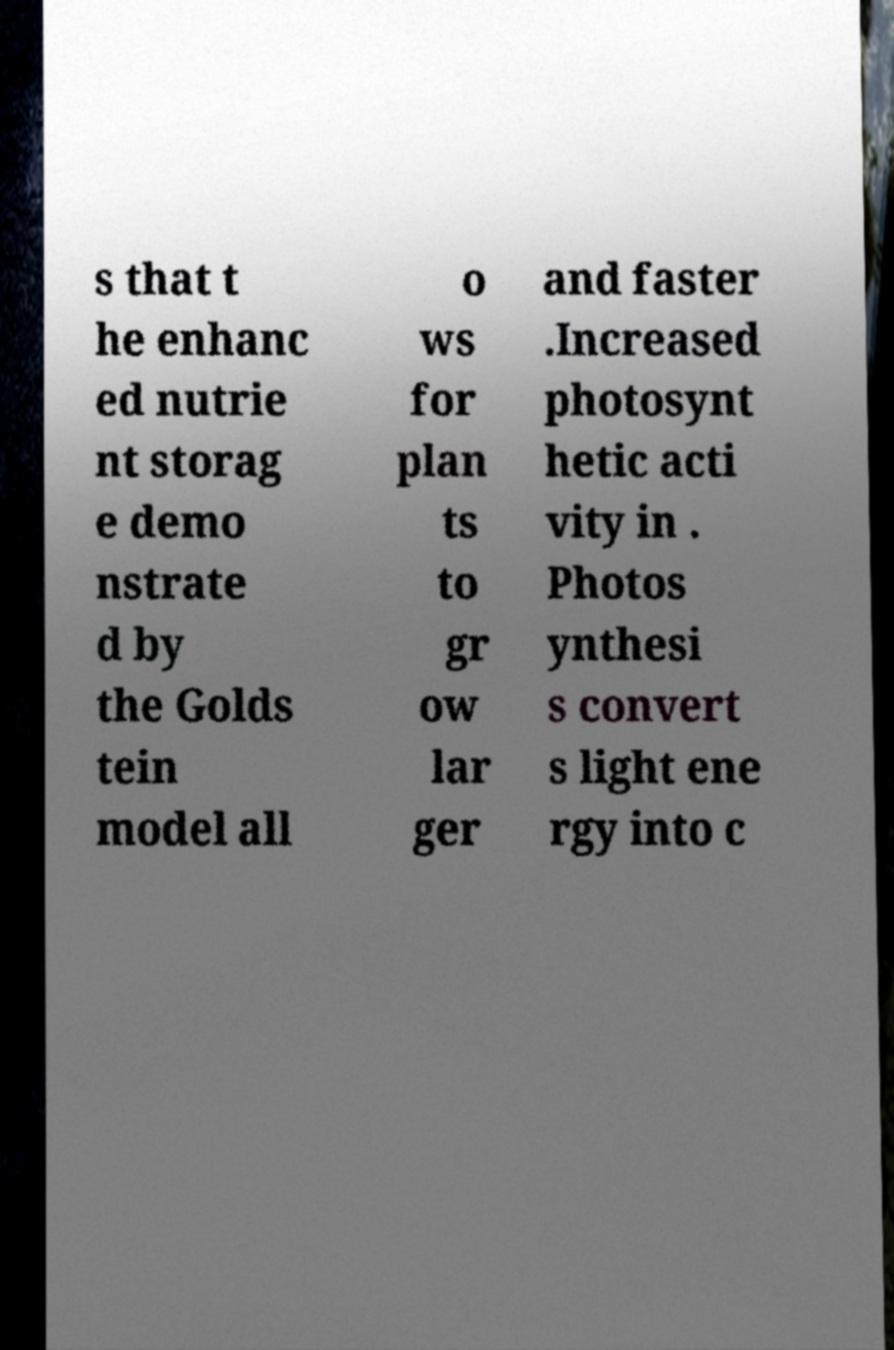Could you extract and type out the text from this image? s that t he enhanc ed nutrie nt storag e demo nstrate d by the Golds tein model all o ws for plan ts to gr ow lar ger and faster .Increased photosynt hetic acti vity in . Photos ynthesi s convert s light ene rgy into c 